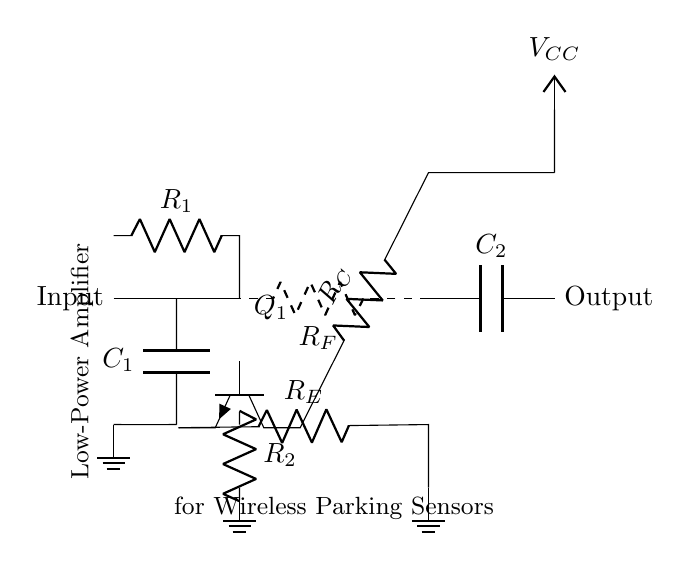What component is used for input filtering? The capacitor labeled C1 is used for input filtering, which helps to block DC while allowing AC signals to pass through.
Answer: Capacitor What is the role of resistor R1 in this circuit? Resistor R1 is used as a biasing resistor to set the base current of the transistor Q1, which controls its operation in the amplifier configuration.
Answer: Biasing resistor What is the function of capacitor C2? Capacitor C2 is used for coupling the output signal, allowing AC signals to pass while blocking any DC component from the output.
Answer: Coupling What does R_E do in the transistor Q1? Resistor R_E provides a path for emitter current, which stabilizes the operating point of the transistor and enhances linearity in amplification.
Answer: Stabilizes operating point How is feedback implemented in this amplifier circuit? Feedback is implemented using resistor R_F, which connects the output back to the input, helping to control the gain and improve stability.
Answer: Resistor R_F What type of transistor is used in this amplifier? The transistor used is an NPN transistor, indicated by the npn symbol in the circuit diagram, which suggests the direction of current flow.
Answer: NPN What is the designation for the power supply voltage in this circuit? The power supply voltage is designated as V_CC, which indicates the supply voltage for powering the amplifier circuit.
Answer: V_CC 